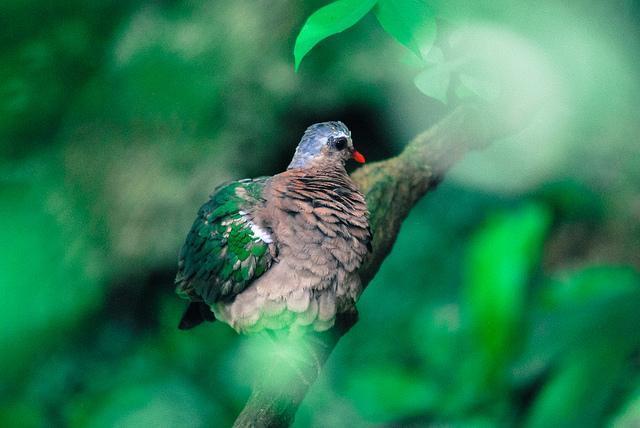How many people are holding skateboards?
Give a very brief answer. 0. 